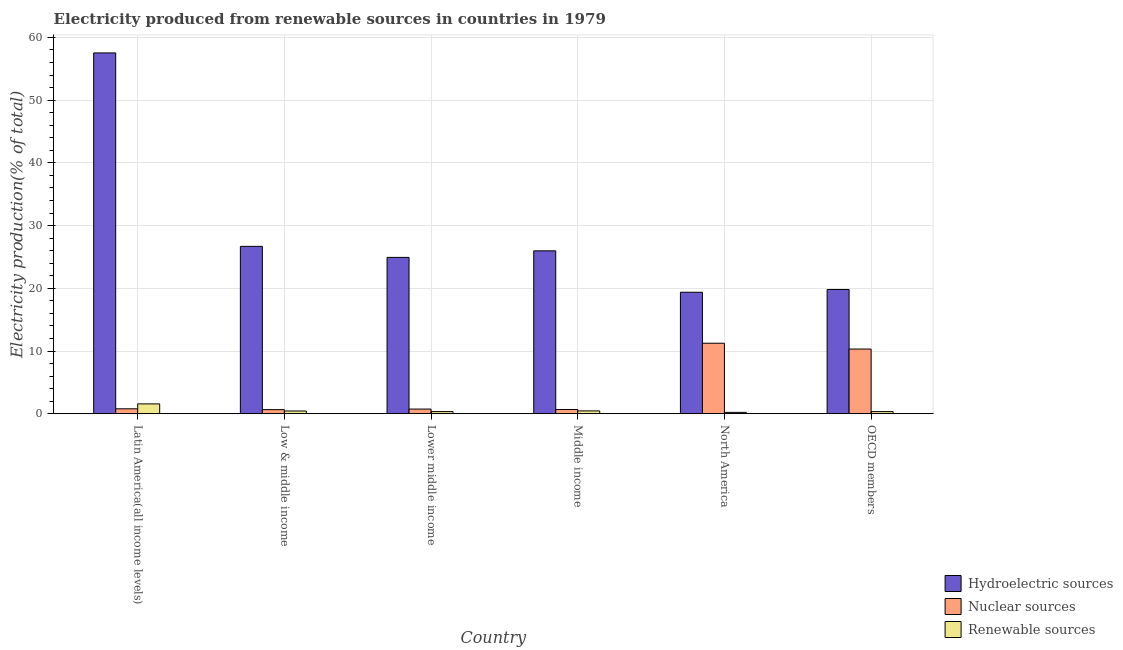How many different coloured bars are there?
Your answer should be compact. 3. How many groups of bars are there?
Keep it short and to the point. 6. Are the number of bars per tick equal to the number of legend labels?
Offer a terse response. Yes. Are the number of bars on each tick of the X-axis equal?
Make the answer very short. Yes. How many bars are there on the 4th tick from the left?
Keep it short and to the point. 3. How many bars are there on the 5th tick from the right?
Keep it short and to the point. 3. What is the label of the 5th group of bars from the left?
Your response must be concise. North America. In how many cases, is the number of bars for a given country not equal to the number of legend labels?
Your response must be concise. 0. What is the percentage of electricity produced by hydroelectric sources in Latin America(all income levels)?
Keep it short and to the point. 57.52. Across all countries, what is the maximum percentage of electricity produced by renewable sources?
Offer a very short reply. 1.57. Across all countries, what is the minimum percentage of electricity produced by hydroelectric sources?
Your answer should be very brief. 19.36. In which country was the percentage of electricity produced by hydroelectric sources maximum?
Your answer should be compact. Latin America(all income levels). In which country was the percentage of electricity produced by hydroelectric sources minimum?
Give a very brief answer. North America. What is the total percentage of electricity produced by renewable sources in the graph?
Provide a short and direct response. 3.36. What is the difference between the percentage of electricity produced by nuclear sources in North America and that in OECD members?
Ensure brevity in your answer.  0.93. What is the difference between the percentage of electricity produced by nuclear sources in Lower middle income and the percentage of electricity produced by hydroelectric sources in Low & middle income?
Provide a succinct answer. -25.94. What is the average percentage of electricity produced by renewable sources per country?
Provide a succinct answer. 0.56. What is the difference between the percentage of electricity produced by renewable sources and percentage of electricity produced by nuclear sources in Latin America(all income levels)?
Provide a succinct answer. 0.78. In how many countries, is the percentage of electricity produced by hydroelectric sources greater than 56 %?
Your response must be concise. 1. What is the ratio of the percentage of electricity produced by renewable sources in Lower middle income to that in OECD members?
Offer a very short reply. 1.01. Is the percentage of electricity produced by renewable sources in Lower middle income less than that in OECD members?
Your response must be concise. No. What is the difference between the highest and the second highest percentage of electricity produced by renewable sources?
Provide a short and direct response. 1.12. What is the difference between the highest and the lowest percentage of electricity produced by nuclear sources?
Keep it short and to the point. 10.59. In how many countries, is the percentage of electricity produced by renewable sources greater than the average percentage of electricity produced by renewable sources taken over all countries?
Provide a short and direct response. 1. What does the 3rd bar from the left in North America represents?
Make the answer very short. Renewable sources. What does the 2nd bar from the right in Latin America(all income levels) represents?
Provide a short and direct response. Nuclear sources. How many bars are there?
Your response must be concise. 18. Are the values on the major ticks of Y-axis written in scientific E-notation?
Offer a terse response. No. Does the graph contain grids?
Your answer should be compact. Yes. How many legend labels are there?
Your answer should be compact. 3. What is the title of the graph?
Make the answer very short. Electricity produced from renewable sources in countries in 1979. Does "Labor Tax" appear as one of the legend labels in the graph?
Provide a succinct answer. No. What is the label or title of the X-axis?
Ensure brevity in your answer.  Country. What is the Electricity production(% of total) in Hydroelectric sources in Latin America(all income levels)?
Provide a succinct answer. 57.52. What is the Electricity production(% of total) of Nuclear sources in Latin America(all income levels)?
Offer a terse response. 0.79. What is the Electricity production(% of total) in Renewable sources in Latin America(all income levels)?
Ensure brevity in your answer.  1.57. What is the Electricity production(% of total) in Hydroelectric sources in Low & middle income?
Make the answer very short. 26.68. What is the Electricity production(% of total) of Nuclear sources in Low & middle income?
Give a very brief answer. 0.66. What is the Electricity production(% of total) in Renewable sources in Low & middle income?
Make the answer very short. 0.44. What is the Electricity production(% of total) in Hydroelectric sources in Lower middle income?
Provide a short and direct response. 24.92. What is the Electricity production(% of total) in Nuclear sources in Lower middle income?
Offer a very short reply. 0.74. What is the Electricity production(% of total) in Renewable sources in Lower middle income?
Provide a succinct answer. 0.34. What is the Electricity production(% of total) in Hydroelectric sources in Middle income?
Give a very brief answer. 25.97. What is the Electricity production(% of total) of Nuclear sources in Middle income?
Provide a short and direct response. 0.68. What is the Electricity production(% of total) of Renewable sources in Middle income?
Give a very brief answer. 0.45. What is the Electricity production(% of total) of Hydroelectric sources in North America?
Your answer should be very brief. 19.36. What is the Electricity production(% of total) in Nuclear sources in North America?
Your answer should be compact. 11.24. What is the Electricity production(% of total) in Renewable sources in North America?
Make the answer very short. 0.22. What is the Electricity production(% of total) of Hydroelectric sources in OECD members?
Make the answer very short. 19.81. What is the Electricity production(% of total) in Nuclear sources in OECD members?
Give a very brief answer. 10.31. What is the Electricity production(% of total) in Renewable sources in OECD members?
Keep it short and to the point. 0.34. Across all countries, what is the maximum Electricity production(% of total) of Hydroelectric sources?
Your response must be concise. 57.52. Across all countries, what is the maximum Electricity production(% of total) in Nuclear sources?
Offer a very short reply. 11.24. Across all countries, what is the maximum Electricity production(% of total) of Renewable sources?
Make the answer very short. 1.57. Across all countries, what is the minimum Electricity production(% of total) of Hydroelectric sources?
Offer a terse response. 19.36. Across all countries, what is the minimum Electricity production(% of total) in Nuclear sources?
Offer a very short reply. 0.66. Across all countries, what is the minimum Electricity production(% of total) of Renewable sources?
Your response must be concise. 0.22. What is the total Electricity production(% of total) in Hydroelectric sources in the graph?
Offer a very short reply. 174.27. What is the total Electricity production(% of total) in Nuclear sources in the graph?
Provide a short and direct response. 24.42. What is the total Electricity production(% of total) in Renewable sources in the graph?
Offer a very short reply. 3.36. What is the difference between the Electricity production(% of total) in Hydroelectric sources in Latin America(all income levels) and that in Low & middle income?
Provide a short and direct response. 30.84. What is the difference between the Electricity production(% of total) of Nuclear sources in Latin America(all income levels) and that in Low & middle income?
Your response must be concise. 0.13. What is the difference between the Electricity production(% of total) in Renewable sources in Latin America(all income levels) and that in Low & middle income?
Your answer should be compact. 1.13. What is the difference between the Electricity production(% of total) in Hydroelectric sources in Latin America(all income levels) and that in Lower middle income?
Keep it short and to the point. 32.6. What is the difference between the Electricity production(% of total) in Nuclear sources in Latin America(all income levels) and that in Lower middle income?
Your response must be concise. 0.04. What is the difference between the Electricity production(% of total) in Renewable sources in Latin America(all income levels) and that in Lower middle income?
Make the answer very short. 1.22. What is the difference between the Electricity production(% of total) of Hydroelectric sources in Latin America(all income levels) and that in Middle income?
Keep it short and to the point. 31.55. What is the difference between the Electricity production(% of total) in Nuclear sources in Latin America(all income levels) and that in Middle income?
Offer a terse response. 0.11. What is the difference between the Electricity production(% of total) in Renewable sources in Latin America(all income levels) and that in Middle income?
Ensure brevity in your answer.  1.12. What is the difference between the Electricity production(% of total) of Hydroelectric sources in Latin America(all income levels) and that in North America?
Give a very brief answer. 38.16. What is the difference between the Electricity production(% of total) of Nuclear sources in Latin America(all income levels) and that in North America?
Your answer should be compact. -10.45. What is the difference between the Electricity production(% of total) in Renewable sources in Latin America(all income levels) and that in North America?
Give a very brief answer. 1.35. What is the difference between the Electricity production(% of total) in Hydroelectric sources in Latin America(all income levels) and that in OECD members?
Provide a short and direct response. 37.71. What is the difference between the Electricity production(% of total) of Nuclear sources in Latin America(all income levels) and that in OECD members?
Provide a short and direct response. -9.52. What is the difference between the Electricity production(% of total) of Renewable sources in Latin America(all income levels) and that in OECD members?
Make the answer very short. 1.23. What is the difference between the Electricity production(% of total) in Hydroelectric sources in Low & middle income and that in Lower middle income?
Provide a succinct answer. 1.76. What is the difference between the Electricity production(% of total) in Nuclear sources in Low & middle income and that in Lower middle income?
Your answer should be compact. -0.09. What is the difference between the Electricity production(% of total) of Renewable sources in Low & middle income and that in Lower middle income?
Keep it short and to the point. 0.09. What is the difference between the Electricity production(% of total) in Hydroelectric sources in Low & middle income and that in Middle income?
Your answer should be very brief. 0.72. What is the difference between the Electricity production(% of total) in Nuclear sources in Low & middle income and that in Middle income?
Your response must be concise. -0.02. What is the difference between the Electricity production(% of total) in Renewable sources in Low & middle income and that in Middle income?
Give a very brief answer. -0.01. What is the difference between the Electricity production(% of total) in Hydroelectric sources in Low & middle income and that in North America?
Provide a short and direct response. 7.32. What is the difference between the Electricity production(% of total) of Nuclear sources in Low & middle income and that in North America?
Your response must be concise. -10.59. What is the difference between the Electricity production(% of total) in Renewable sources in Low & middle income and that in North America?
Provide a short and direct response. 0.22. What is the difference between the Electricity production(% of total) in Hydroelectric sources in Low & middle income and that in OECD members?
Your response must be concise. 6.88. What is the difference between the Electricity production(% of total) in Nuclear sources in Low & middle income and that in OECD members?
Ensure brevity in your answer.  -9.66. What is the difference between the Electricity production(% of total) in Renewable sources in Low & middle income and that in OECD members?
Provide a short and direct response. 0.1. What is the difference between the Electricity production(% of total) of Hydroelectric sources in Lower middle income and that in Middle income?
Offer a very short reply. -1.04. What is the difference between the Electricity production(% of total) of Nuclear sources in Lower middle income and that in Middle income?
Make the answer very short. 0.07. What is the difference between the Electricity production(% of total) in Renewable sources in Lower middle income and that in Middle income?
Your response must be concise. -0.11. What is the difference between the Electricity production(% of total) of Hydroelectric sources in Lower middle income and that in North America?
Provide a succinct answer. 5.56. What is the difference between the Electricity production(% of total) in Nuclear sources in Lower middle income and that in North America?
Offer a very short reply. -10.5. What is the difference between the Electricity production(% of total) in Renewable sources in Lower middle income and that in North America?
Your answer should be very brief. 0.12. What is the difference between the Electricity production(% of total) of Hydroelectric sources in Lower middle income and that in OECD members?
Provide a succinct answer. 5.12. What is the difference between the Electricity production(% of total) in Nuclear sources in Lower middle income and that in OECD members?
Provide a short and direct response. -9.57. What is the difference between the Electricity production(% of total) of Renewable sources in Lower middle income and that in OECD members?
Your answer should be compact. 0. What is the difference between the Electricity production(% of total) of Hydroelectric sources in Middle income and that in North America?
Provide a succinct answer. 6.6. What is the difference between the Electricity production(% of total) of Nuclear sources in Middle income and that in North America?
Provide a succinct answer. -10.56. What is the difference between the Electricity production(% of total) of Renewable sources in Middle income and that in North America?
Your response must be concise. 0.23. What is the difference between the Electricity production(% of total) of Hydroelectric sources in Middle income and that in OECD members?
Keep it short and to the point. 6.16. What is the difference between the Electricity production(% of total) of Nuclear sources in Middle income and that in OECD members?
Offer a very short reply. -9.63. What is the difference between the Electricity production(% of total) of Renewable sources in Middle income and that in OECD members?
Ensure brevity in your answer.  0.11. What is the difference between the Electricity production(% of total) of Hydroelectric sources in North America and that in OECD members?
Provide a short and direct response. -0.44. What is the difference between the Electricity production(% of total) of Nuclear sources in North America and that in OECD members?
Offer a terse response. 0.93. What is the difference between the Electricity production(% of total) of Renewable sources in North America and that in OECD members?
Keep it short and to the point. -0.12. What is the difference between the Electricity production(% of total) in Hydroelectric sources in Latin America(all income levels) and the Electricity production(% of total) in Nuclear sources in Low & middle income?
Keep it short and to the point. 56.87. What is the difference between the Electricity production(% of total) in Hydroelectric sources in Latin America(all income levels) and the Electricity production(% of total) in Renewable sources in Low & middle income?
Your response must be concise. 57.08. What is the difference between the Electricity production(% of total) of Nuclear sources in Latin America(all income levels) and the Electricity production(% of total) of Renewable sources in Low & middle income?
Keep it short and to the point. 0.35. What is the difference between the Electricity production(% of total) of Hydroelectric sources in Latin America(all income levels) and the Electricity production(% of total) of Nuclear sources in Lower middle income?
Make the answer very short. 56.78. What is the difference between the Electricity production(% of total) in Hydroelectric sources in Latin America(all income levels) and the Electricity production(% of total) in Renewable sources in Lower middle income?
Offer a terse response. 57.18. What is the difference between the Electricity production(% of total) of Nuclear sources in Latin America(all income levels) and the Electricity production(% of total) of Renewable sources in Lower middle income?
Provide a succinct answer. 0.44. What is the difference between the Electricity production(% of total) of Hydroelectric sources in Latin America(all income levels) and the Electricity production(% of total) of Nuclear sources in Middle income?
Your answer should be compact. 56.84. What is the difference between the Electricity production(% of total) in Hydroelectric sources in Latin America(all income levels) and the Electricity production(% of total) in Renewable sources in Middle income?
Keep it short and to the point. 57.07. What is the difference between the Electricity production(% of total) in Nuclear sources in Latin America(all income levels) and the Electricity production(% of total) in Renewable sources in Middle income?
Your response must be concise. 0.33. What is the difference between the Electricity production(% of total) in Hydroelectric sources in Latin America(all income levels) and the Electricity production(% of total) in Nuclear sources in North America?
Ensure brevity in your answer.  46.28. What is the difference between the Electricity production(% of total) of Hydroelectric sources in Latin America(all income levels) and the Electricity production(% of total) of Renewable sources in North America?
Your answer should be compact. 57.3. What is the difference between the Electricity production(% of total) of Nuclear sources in Latin America(all income levels) and the Electricity production(% of total) of Renewable sources in North America?
Keep it short and to the point. 0.57. What is the difference between the Electricity production(% of total) of Hydroelectric sources in Latin America(all income levels) and the Electricity production(% of total) of Nuclear sources in OECD members?
Your answer should be very brief. 47.21. What is the difference between the Electricity production(% of total) of Hydroelectric sources in Latin America(all income levels) and the Electricity production(% of total) of Renewable sources in OECD members?
Offer a terse response. 57.18. What is the difference between the Electricity production(% of total) of Nuclear sources in Latin America(all income levels) and the Electricity production(% of total) of Renewable sources in OECD members?
Ensure brevity in your answer.  0.45. What is the difference between the Electricity production(% of total) in Hydroelectric sources in Low & middle income and the Electricity production(% of total) in Nuclear sources in Lower middle income?
Keep it short and to the point. 25.94. What is the difference between the Electricity production(% of total) in Hydroelectric sources in Low & middle income and the Electricity production(% of total) in Renewable sources in Lower middle income?
Your answer should be compact. 26.34. What is the difference between the Electricity production(% of total) in Nuclear sources in Low & middle income and the Electricity production(% of total) in Renewable sources in Lower middle income?
Your response must be concise. 0.31. What is the difference between the Electricity production(% of total) in Hydroelectric sources in Low & middle income and the Electricity production(% of total) in Nuclear sources in Middle income?
Make the answer very short. 26.01. What is the difference between the Electricity production(% of total) of Hydroelectric sources in Low & middle income and the Electricity production(% of total) of Renewable sources in Middle income?
Your answer should be very brief. 26.23. What is the difference between the Electricity production(% of total) in Nuclear sources in Low & middle income and the Electricity production(% of total) in Renewable sources in Middle income?
Make the answer very short. 0.2. What is the difference between the Electricity production(% of total) of Hydroelectric sources in Low & middle income and the Electricity production(% of total) of Nuclear sources in North America?
Provide a succinct answer. 15.44. What is the difference between the Electricity production(% of total) of Hydroelectric sources in Low & middle income and the Electricity production(% of total) of Renewable sources in North America?
Your answer should be compact. 26.46. What is the difference between the Electricity production(% of total) in Nuclear sources in Low & middle income and the Electricity production(% of total) in Renewable sources in North America?
Provide a short and direct response. 0.44. What is the difference between the Electricity production(% of total) of Hydroelectric sources in Low & middle income and the Electricity production(% of total) of Nuclear sources in OECD members?
Make the answer very short. 16.37. What is the difference between the Electricity production(% of total) in Hydroelectric sources in Low & middle income and the Electricity production(% of total) in Renewable sources in OECD members?
Your answer should be compact. 26.34. What is the difference between the Electricity production(% of total) in Nuclear sources in Low & middle income and the Electricity production(% of total) in Renewable sources in OECD members?
Provide a short and direct response. 0.31. What is the difference between the Electricity production(% of total) in Hydroelectric sources in Lower middle income and the Electricity production(% of total) in Nuclear sources in Middle income?
Offer a terse response. 24.25. What is the difference between the Electricity production(% of total) in Hydroelectric sources in Lower middle income and the Electricity production(% of total) in Renewable sources in Middle income?
Offer a very short reply. 24.47. What is the difference between the Electricity production(% of total) in Nuclear sources in Lower middle income and the Electricity production(% of total) in Renewable sources in Middle income?
Your response must be concise. 0.29. What is the difference between the Electricity production(% of total) of Hydroelectric sources in Lower middle income and the Electricity production(% of total) of Nuclear sources in North America?
Offer a terse response. 13.68. What is the difference between the Electricity production(% of total) of Hydroelectric sources in Lower middle income and the Electricity production(% of total) of Renewable sources in North America?
Your response must be concise. 24.7. What is the difference between the Electricity production(% of total) in Nuclear sources in Lower middle income and the Electricity production(% of total) in Renewable sources in North America?
Offer a very short reply. 0.52. What is the difference between the Electricity production(% of total) of Hydroelectric sources in Lower middle income and the Electricity production(% of total) of Nuclear sources in OECD members?
Your answer should be very brief. 14.61. What is the difference between the Electricity production(% of total) in Hydroelectric sources in Lower middle income and the Electricity production(% of total) in Renewable sources in OECD members?
Your response must be concise. 24.58. What is the difference between the Electricity production(% of total) in Nuclear sources in Lower middle income and the Electricity production(% of total) in Renewable sources in OECD members?
Provide a succinct answer. 0.4. What is the difference between the Electricity production(% of total) of Hydroelectric sources in Middle income and the Electricity production(% of total) of Nuclear sources in North America?
Your answer should be very brief. 14.73. What is the difference between the Electricity production(% of total) in Hydroelectric sources in Middle income and the Electricity production(% of total) in Renewable sources in North America?
Your answer should be compact. 25.75. What is the difference between the Electricity production(% of total) of Nuclear sources in Middle income and the Electricity production(% of total) of Renewable sources in North America?
Give a very brief answer. 0.46. What is the difference between the Electricity production(% of total) of Hydroelectric sources in Middle income and the Electricity production(% of total) of Nuclear sources in OECD members?
Offer a very short reply. 15.66. What is the difference between the Electricity production(% of total) in Hydroelectric sources in Middle income and the Electricity production(% of total) in Renewable sources in OECD members?
Offer a terse response. 25.63. What is the difference between the Electricity production(% of total) in Nuclear sources in Middle income and the Electricity production(% of total) in Renewable sources in OECD members?
Provide a succinct answer. 0.34. What is the difference between the Electricity production(% of total) of Hydroelectric sources in North America and the Electricity production(% of total) of Nuclear sources in OECD members?
Ensure brevity in your answer.  9.05. What is the difference between the Electricity production(% of total) in Hydroelectric sources in North America and the Electricity production(% of total) in Renewable sources in OECD members?
Provide a succinct answer. 19.02. What is the difference between the Electricity production(% of total) in Nuclear sources in North America and the Electricity production(% of total) in Renewable sources in OECD members?
Ensure brevity in your answer.  10.9. What is the average Electricity production(% of total) of Hydroelectric sources per country?
Provide a succinct answer. 29.04. What is the average Electricity production(% of total) of Nuclear sources per country?
Ensure brevity in your answer.  4.07. What is the average Electricity production(% of total) of Renewable sources per country?
Offer a terse response. 0.56. What is the difference between the Electricity production(% of total) in Hydroelectric sources and Electricity production(% of total) in Nuclear sources in Latin America(all income levels)?
Make the answer very short. 56.73. What is the difference between the Electricity production(% of total) in Hydroelectric sources and Electricity production(% of total) in Renewable sources in Latin America(all income levels)?
Provide a succinct answer. 55.95. What is the difference between the Electricity production(% of total) in Nuclear sources and Electricity production(% of total) in Renewable sources in Latin America(all income levels)?
Ensure brevity in your answer.  -0.78. What is the difference between the Electricity production(% of total) of Hydroelectric sources and Electricity production(% of total) of Nuclear sources in Low & middle income?
Make the answer very short. 26.03. What is the difference between the Electricity production(% of total) of Hydroelectric sources and Electricity production(% of total) of Renewable sources in Low & middle income?
Keep it short and to the point. 26.25. What is the difference between the Electricity production(% of total) of Nuclear sources and Electricity production(% of total) of Renewable sources in Low & middle income?
Your answer should be very brief. 0.22. What is the difference between the Electricity production(% of total) of Hydroelectric sources and Electricity production(% of total) of Nuclear sources in Lower middle income?
Provide a succinct answer. 24.18. What is the difference between the Electricity production(% of total) of Hydroelectric sources and Electricity production(% of total) of Renewable sources in Lower middle income?
Keep it short and to the point. 24.58. What is the difference between the Electricity production(% of total) in Nuclear sources and Electricity production(% of total) in Renewable sources in Lower middle income?
Offer a very short reply. 0.4. What is the difference between the Electricity production(% of total) of Hydroelectric sources and Electricity production(% of total) of Nuclear sources in Middle income?
Offer a very short reply. 25.29. What is the difference between the Electricity production(% of total) in Hydroelectric sources and Electricity production(% of total) in Renewable sources in Middle income?
Ensure brevity in your answer.  25.52. What is the difference between the Electricity production(% of total) of Nuclear sources and Electricity production(% of total) of Renewable sources in Middle income?
Keep it short and to the point. 0.23. What is the difference between the Electricity production(% of total) of Hydroelectric sources and Electricity production(% of total) of Nuclear sources in North America?
Make the answer very short. 8.12. What is the difference between the Electricity production(% of total) of Hydroelectric sources and Electricity production(% of total) of Renewable sources in North America?
Ensure brevity in your answer.  19.15. What is the difference between the Electricity production(% of total) in Nuclear sources and Electricity production(% of total) in Renewable sources in North America?
Ensure brevity in your answer.  11.02. What is the difference between the Electricity production(% of total) of Hydroelectric sources and Electricity production(% of total) of Nuclear sources in OECD members?
Keep it short and to the point. 9.5. What is the difference between the Electricity production(% of total) in Hydroelectric sources and Electricity production(% of total) in Renewable sources in OECD members?
Keep it short and to the point. 19.47. What is the difference between the Electricity production(% of total) in Nuclear sources and Electricity production(% of total) in Renewable sources in OECD members?
Give a very brief answer. 9.97. What is the ratio of the Electricity production(% of total) in Hydroelectric sources in Latin America(all income levels) to that in Low & middle income?
Your answer should be compact. 2.16. What is the ratio of the Electricity production(% of total) of Nuclear sources in Latin America(all income levels) to that in Low & middle income?
Your response must be concise. 1.2. What is the ratio of the Electricity production(% of total) of Renewable sources in Latin America(all income levels) to that in Low & middle income?
Ensure brevity in your answer.  3.58. What is the ratio of the Electricity production(% of total) of Hydroelectric sources in Latin America(all income levels) to that in Lower middle income?
Your answer should be compact. 2.31. What is the ratio of the Electricity production(% of total) in Nuclear sources in Latin America(all income levels) to that in Lower middle income?
Ensure brevity in your answer.  1.06. What is the ratio of the Electricity production(% of total) of Renewable sources in Latin America(all income levels) to that in Lower middle income?
Your answer should be very brief. 4.56. What is the ratio of the Electricity production(% of total) of Hydroelectric sources in Latin America(all income levels) to that in Middle income?
Provide a succinct answer. 2.22. What is the ratio of the Electricity production(% of total) of Nuclear sources in Latin America(all income levels) to that in Middle income?
Your answer should be compact. 1.16. What is the ratio of the Electricity production(% of total) in Renewable sources in Latin America(all income levels) to that in Middle income?
Provide a succinct answer. 3.47. What is the ratio of the Electricity production(% of total) in Hydroelectric sources in Latin America(all income levels) to that in North America?
Make the answer very short. 2.97. What is the ratio of the Electricity production(% of total) of Nuclear sources in Latin America(all income levels) to that in North America?
Your response must be concise. 0.07. What is the ratio of the Electricity production(% of total) in Renewable sources in Latin America(all income levels) to that in North America?
Make the answer very short. 7.14. What is the ratio of the Electricity production(% of total) in Hydroelectric sources in Latin America(all income levels) to that in OECD members?
Offer a terse response. 2.9. What is the ratio of the Electricity production(% of total) in Nuclear sources in Latin America(all income levels) to that in OECD members?
Your answer should be very brief. 0.08. What is the ratio of the Electricity production(% of total) of Renewable sources in Latin America(all income levels) to that in OECD members?
Your answer should be very brief. 4.6. What is the ratio of the Electricity production(% of total) in Hydroelectric sources in Low & middle income to that in Lower middle income?
Offer a terse response. 1.07. What is the ratio of the Electricity production(% of total) of Nuclear sources in Low & middle income to that in Lower middle income?
Your response must be concise. 0.88. What is the ratio of the Electricity production(% of total) of Renewable sources in Low & middle income to that in Lower middle income?
Ensure brevity in your answer.  1.27. What is the ratio of the Electricity production(% of total) of Hydroelectric sources in Low & middle income to that in Middle income?
Your response must be concise. 1.03. What is the ratio of the Electricity production(% of total) of Nuclear sources in Low & middle income to that in Middle income?
Give a very brief answer. 0.97. What is the ratio of the Electricity production(% of total) in Renewable sources in Low & middle income to that in Middle income?
Your answer should be compact. 0.97. What is the ratio of the Electricity production(% of total) in Hydroelectric sources in Low & middle income to that in North America?
Your answer should be compact. 1.38. What is the ratio of the Electricity production(% of total) of Nuclear sources in Low & middle income to that in North America?
Offer a terse response. 0.06. What is the ratio of the Electricity production(% of total) in Renewable sources in Low & middle income to that in North America?
Provide a succinct answer. 1.99. What is the ratio of the Electricity production(% of total) of Hydroelectric sources in Low & middle income to that in OECD members?
Offer a terse response. 1.35. What is the ratio of the Electricity production(% of total) in Nuclear sources in Low & middle income to that in OECD members?
Make the answer very short. 0.06. What is the ratio of the Electricity production(% of total) of Renewable sources in Low & middle income to that in OECD members?
Make the answer very short. 1.29. What is the ratio of the Electricity production(% of total) of Hydroelectric sources in Lower middle income to that in Middle income?
Provide a short and direct response. 0.96. What is the ratio of the Electricity production(% of total) in Nuclear sources in Lower middle income to that in Middle income?
Ensure brevity in your answer.  1.1. What is the ratio of the Electricity production(% of total) in Renewable sources in Lower middle income to that in Middle income?
Keep it short and to the point. 0.76. What is the ratio of the Electricity production(% of total) of Hydroelectric sources in Lower middle income to that in North America?
Provide a short and direct response. 1.29. What is the ratio of the Electricity production(% of total) of Nuclear sources in Lower middle income to that in North America?
Provide a short and direct response. 0.07. What is the ratio of the Electricity production(% of total) in Renewable sources in Lower middle income to that in North America?
Your response must be concise. 1.57. What is the ratio of the Electricity production(% of total) of Hydroelectric sources in Lower middle income to that in OECD members?
Your answer should be very brief. 1.26. What is the ratio of the Electricity production(% of total) in Nuclear sources in Lower middle income to that in OECD members?
Your answer should be compact. 0.07. What is the ratio of the Electricity production(% of total) of Renewable sources in Lower middle income to that in OECD members?
Provide a short and direct response. 1.01. What is the ratio of the Electricity production(% of total) of Hydroelectric sources in Middle income to that in North America?
Your response must be concise. 1.34. What is the ratio of the Electricity production(% of total) in Nuclear sources in Middle income to that in North America?
Ensure brevity in your answer.  0.06. What is the ratio of the Electricity production(% of total) in Renewable sources in Middle income to that in North America?
Offer a terse response. 2.06. What is the ratio of the Electricity production(% of total) of Hydroelectric sources in Middle income to that in OECD members?
Your answer should be very brief. 1.31. What is the ratio of the Electricity production(% of total) in Nuclear sources in Middle income to that in OECD members?
Ensure brevity in your answer.  0.07. What is the ratio of the Electricity production(% of total) in Renewable sources in Middle income to that in OECD members?
Provide a succinct answer. 1.33. What is the ratio of the Electricity production(% of total) of Hydroelectric sources in North America to that in OECD members?
Your response must be concise. 0.98. What is the ratio of the Electricity production(% of total) in Nuclear sources in North America to that in OECD members?
Offer a terse response. 1.09. What is the ratio of the Electricity production(% of total) in Renewable sources in North America to that in OECD members?
Offer a very short reply. 0.64. What is the difference between the highest and the second highest Electricity production(% of total) in Hydroelectric sources?
Make the answer very short. 30.84. What is the difference between the highest and the second highest Electricity production(% of total) in Renewable sources?
Ensure brevity in your answer.  1.12. What is the difference between the highest and the lowest Electricity production(% of total) of Hydroelectric sources?
Offer a terse response. 38.16. What is the difference between the highest and the lowest Electricity production(% of total) in Nuclear sources?
Provide a succinct answer. 10.59. What is the difference between the highest and the lowest Electricity production(% of total) of Renewable sources?
Offer a terse response. 1.35. 